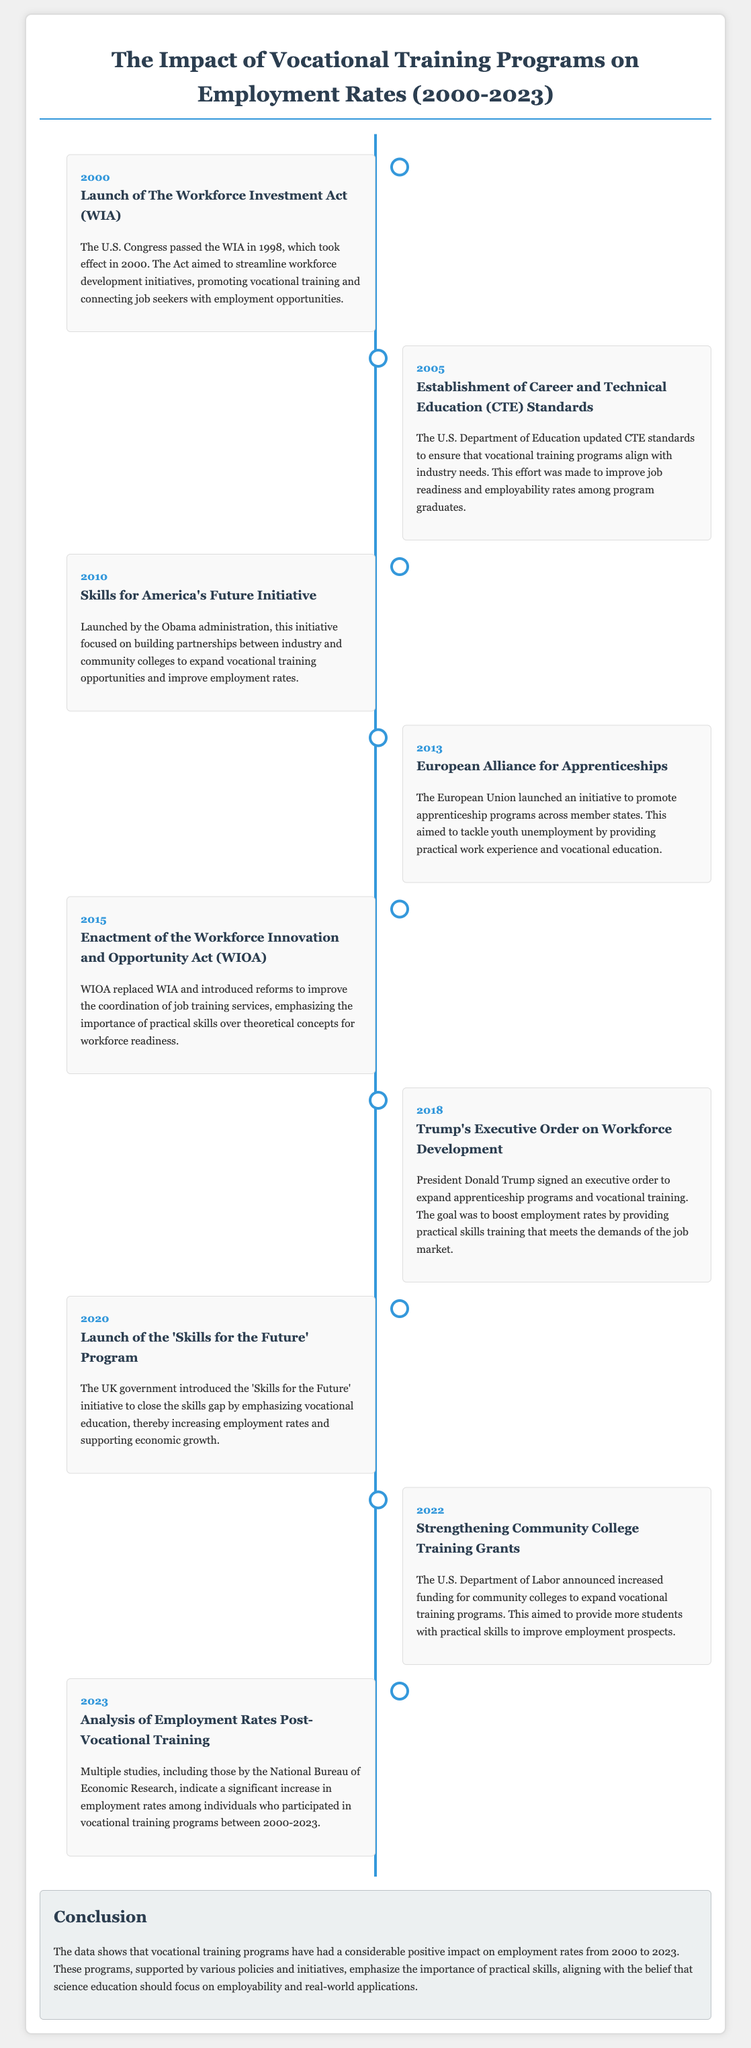What year was the Workforce Investment Act launched? The document states that the Workforce Investment Act took effect in 2000.
Answer: 2000 What initiative focused on building partnerships between industry and community colleges? The initiative mentioned is Skills for America's Future, launched in 2010.
Answer: Skills for America's Future What act replaced the Workforce Investment Act? The document specifies that the Workforce Innovation and Opportunity Act replaced the WIA in 2015.
Answer: Workforce Innovation and Opportunity Act Which president signed an executive order on workforce development? According to the document, President Donald Trump signed the executive order in 2018.
Answer: Donald Trump What was the primary goal of vocational training programs according to the timeline? The timeline indicates that the primary goal is to improve employment rates through practical skills training.
Answer: Improve employment rates Which year saw the announcement of increased funding for community colleges? The document indicates that this occurred in 2022.
Answer: 2022 What was indicated as a significant outcome of vocational training between 2000-2023? The document notes a significant increase in employment rates as an outcome of vocational training.
Answer: Significant increase in employment rates What kind of skills do vocational training programs emphasize? The document emphasizes that vocational training programs focus on practical skills.
Answer: Practical skills What conclusion is drawn about vocational training programs from 2000 to 2023? The conclusion states that vocational training programs have had a considerable positive impact on employment rates.
Answer: Considerable positive impact on employment rates 